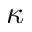<formula> <loc_0><loc_0><loc_500><loc_500>\kappa</formula> 